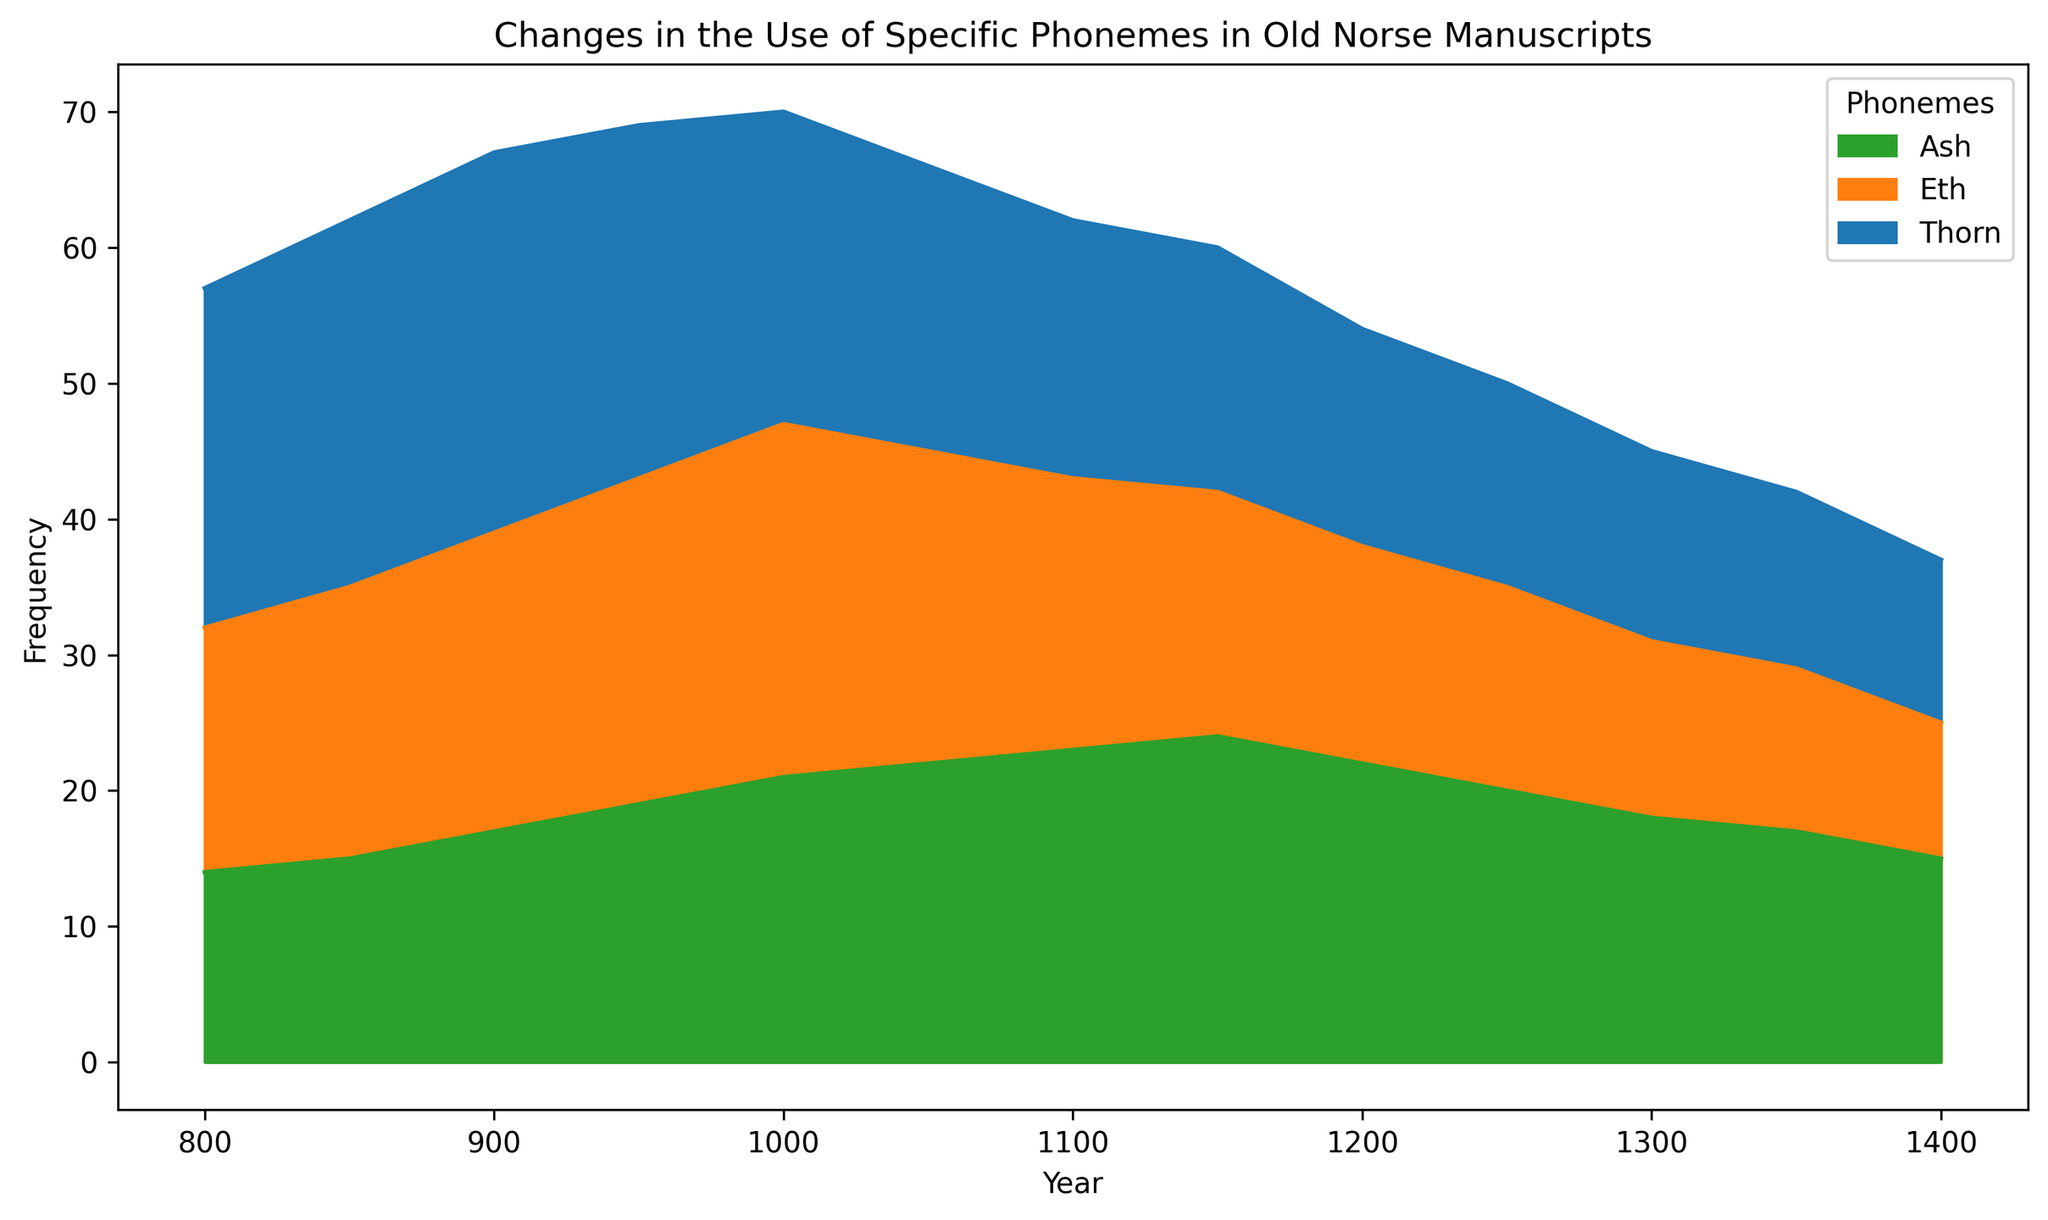What is the trend in the frequency of the phoneme 'Thorn' from 800 to 1400? Observe the area representing the phoneme 'Thorn' (blue) in the chart. From 800 to around 1000, the frequency is relatively high and fluctuates slightly. After 1000, there's a noticeable declining trend, dropping steadily until 1400.
Answer: Declining Which phoneme had the highest frequency in the year 1050? Look at the overlapping areas for the year 1050. The phoneme 'Ash' (green) has a higher peak than 'Thorn' (blue) and 'Eth' (orange).
Answer: Ash How does the frequency of 'Eth' in 1100 compare to its frequency in 800? Identify the heights of the orange areas in 1100 and 800. In 800, 'Eth' is at 18, while in 1100, it is 20. This shows a slight increase.
Answer: Slight increase What is the combined frequency of 'Thorn' and 'Eth' in 900? Add the frequency values for the blue and orange areas in the year 900. 'Thorn' is 28, and 'Eth' is 22. 28 + 22 equals 50.
Answer: 50 What is the overall trend for the phoneme 'Ash' from 800 to 1400? Examine the green area across the entire timeline. There is an overall increasing trend until around 1150, followed by a slight decline but generally remaining higher than initial levels.
Answer: Increasing Which year had the lowest total phoneme frequency and which phoneme contributed the least? Sum the frequencies for each phoneme in all the years. The year 1400 has the lowest total frequency (12 + 10 + 15 = 37). In this year, 'Eth' (orange) contributes the least with a frequency of 10.
Answer: 1400, Eth By how much did the frequency of 'Ash' change from the year 800 to 1200? Compare the heights of the green area in the years 800 (14) and 1200 (22). The change is 22 - 14 = 8.
Answer: Increased by 8 Which phoneme shows the most consistent frequency trend over the timeline? Examine each area for smoothness and lack of sharp fluctuations. 'Ash' (green) shows a steady trend with less variation compared to 'Thorn' and 'Eth'.
Answer: Ash In what year do 'Eth' and 'Ash' frequencies intersect, if at all? Look for an intersection point in the orange and green areas. They intersect in the year 1300, both having a frequency around 13-14.
Answer: 1300 